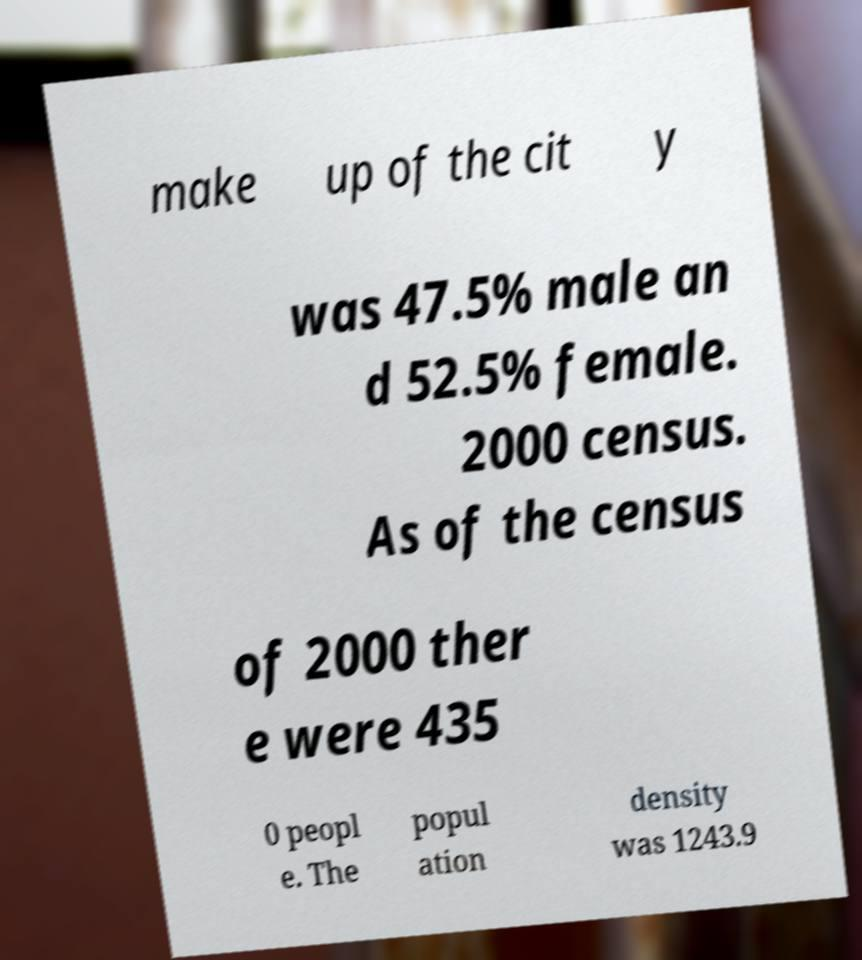What messages or text are displayed in this image? I need them in a readable, typed format. make up of the cit y was 47.5% male an d 52.5% female. 2000 census. As of the census of 2000 ther e were 435 0 peopl e. The popul ation density was 1243.9 